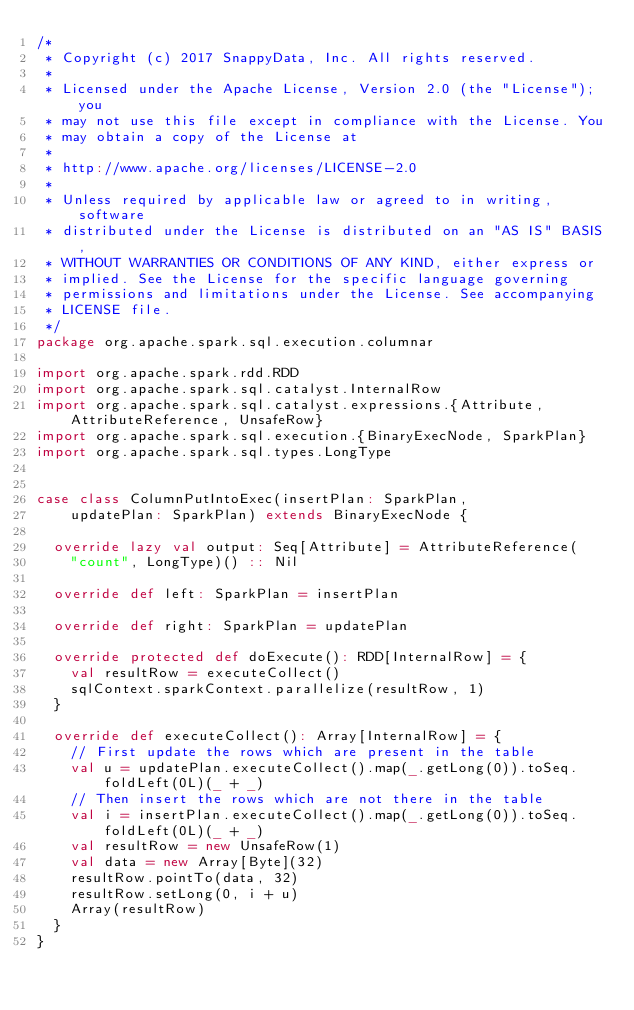<code> <loc_0><loc_0><loc_500><loc_500><_Scala_>/*
 * Copyright (c) 2017 SnappyData, Inc. All rights reserved.
 *
 * Licensed under the Apache License, Version 2.0 (the "License"); you
 * may not use this file except in compliance with the License. You
 * may obtain a copy of the License at
 *
 * http://www.apache.org/licenses/LICENSE-2.0
 *
 * Unless required by applicable law or agreed to in writing, software
 * distributed under the License is distributed on an "AS IS" BASIS,
 * WITHOUT WARRANTIES OR CONDITIONS OF ANY KIND, either express or
 * implied. See the License for the specific language governing
 * permissions and limitations under the License. See accompanying
 * LICENSE file.
 */
package org.apache.spark.sql.execution.columnar

import org.apache.spark.rdd.RDD
import org.apache.spark.sql.catalyst.InternalRow
import org.apache.spark.sql.catalyst.expressions.{Attribute, AttributeReference, UnsafeRow}
import org.apache.spark.sql.execution.{BinaryExecNode, SparkPlan}
import org.apache.spark.sql.types.LongType


case class ColumnPutIntoExec(insertPlan: SparkPlan,
    updatePlan: SparkPlan) extends BinaryExecNode {

  override lazy val output: Seq[Attribute] = AttributeReference(
    "count", LongType)() :: Nil

  override def left: SparkPlan = insertPlan

  override def right: SparkPlan = updatePlan

  override protected def doExecute(): RDD[InternalRow] = {
    val resultRow = executeCollect()
    sqlContext.sparkContext.parallelize(resultRow, 1)
  }

  override def executeCollect(): Array[InternalRow] = {
    // First update the rows which are present in the table
    val u = updatePlan.executeCollect().map(_.getLong(0)).toSeq.foldLeft(0L)(_ + _)
    // Then insert the rows which are not there in the table
    val i = insertPlan.executeCollect().map(_.getLong(0)).toSeq.foldLeft(0L)(_ + _)
    val resultRow = new UnsafeRow(1)
    val data = new Array[Byte](32)
    resultRow.pointTo(data, 32)
    resultRow.setLong(0, i + u)
    Array(resultRow)
  }
}
</code> 